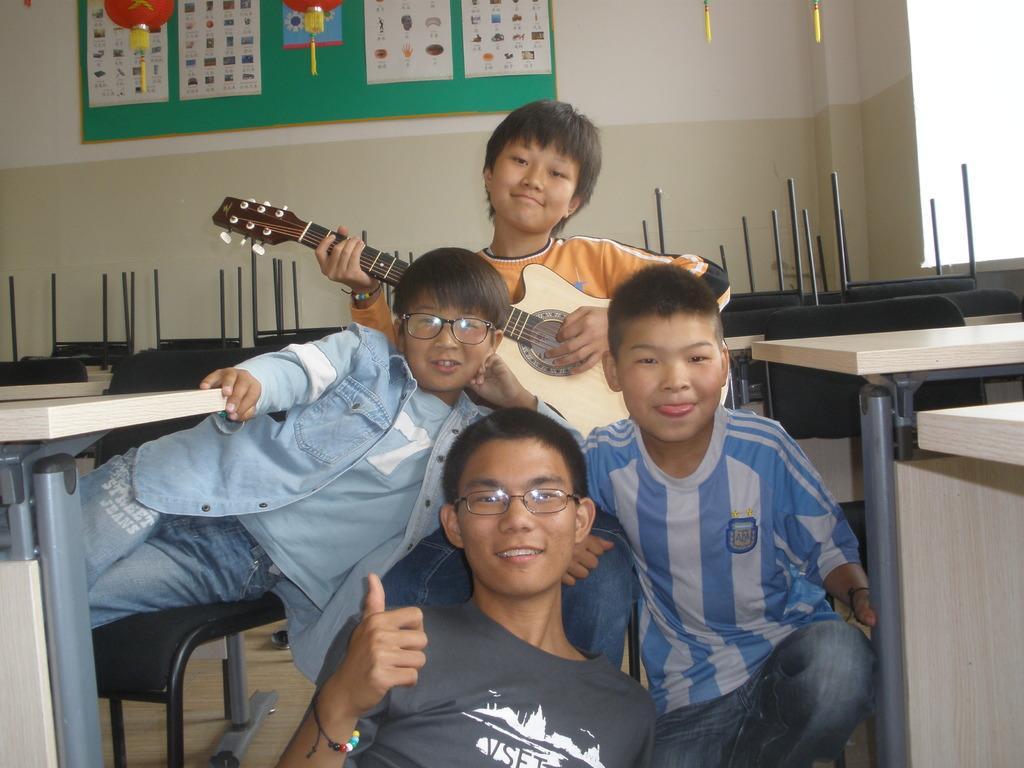Please provide a concise description of this image. In the image we can see there are people who are sitting on floor and at the back there is a man who is holding guitar in his hand. 